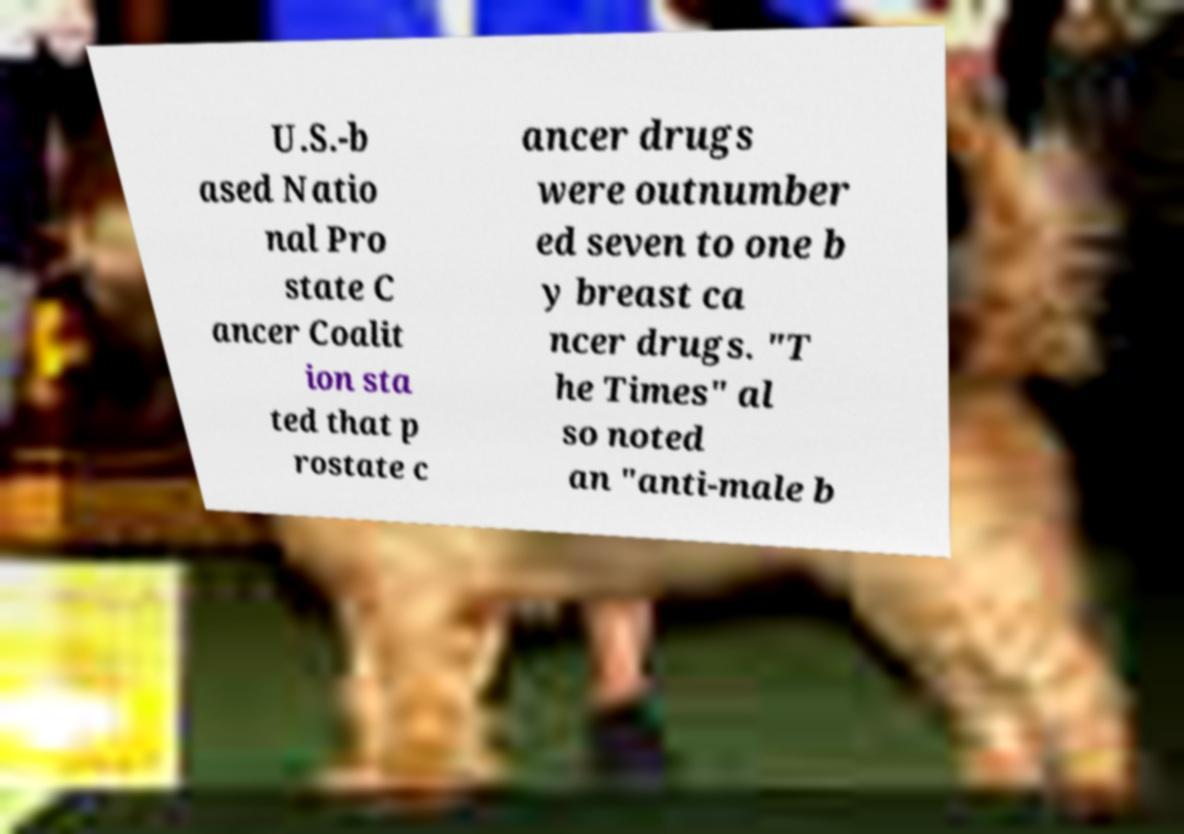Can you accurately transcribe the text from the provided image for me? U.S.-b ased Natio nal Pro state C ancer Coalit ion sta ted that p rostate c ancer drugs were outnumber ed seven to one b y breast ca ncer drugs. "T he Times" al so noted an "anti-male b 